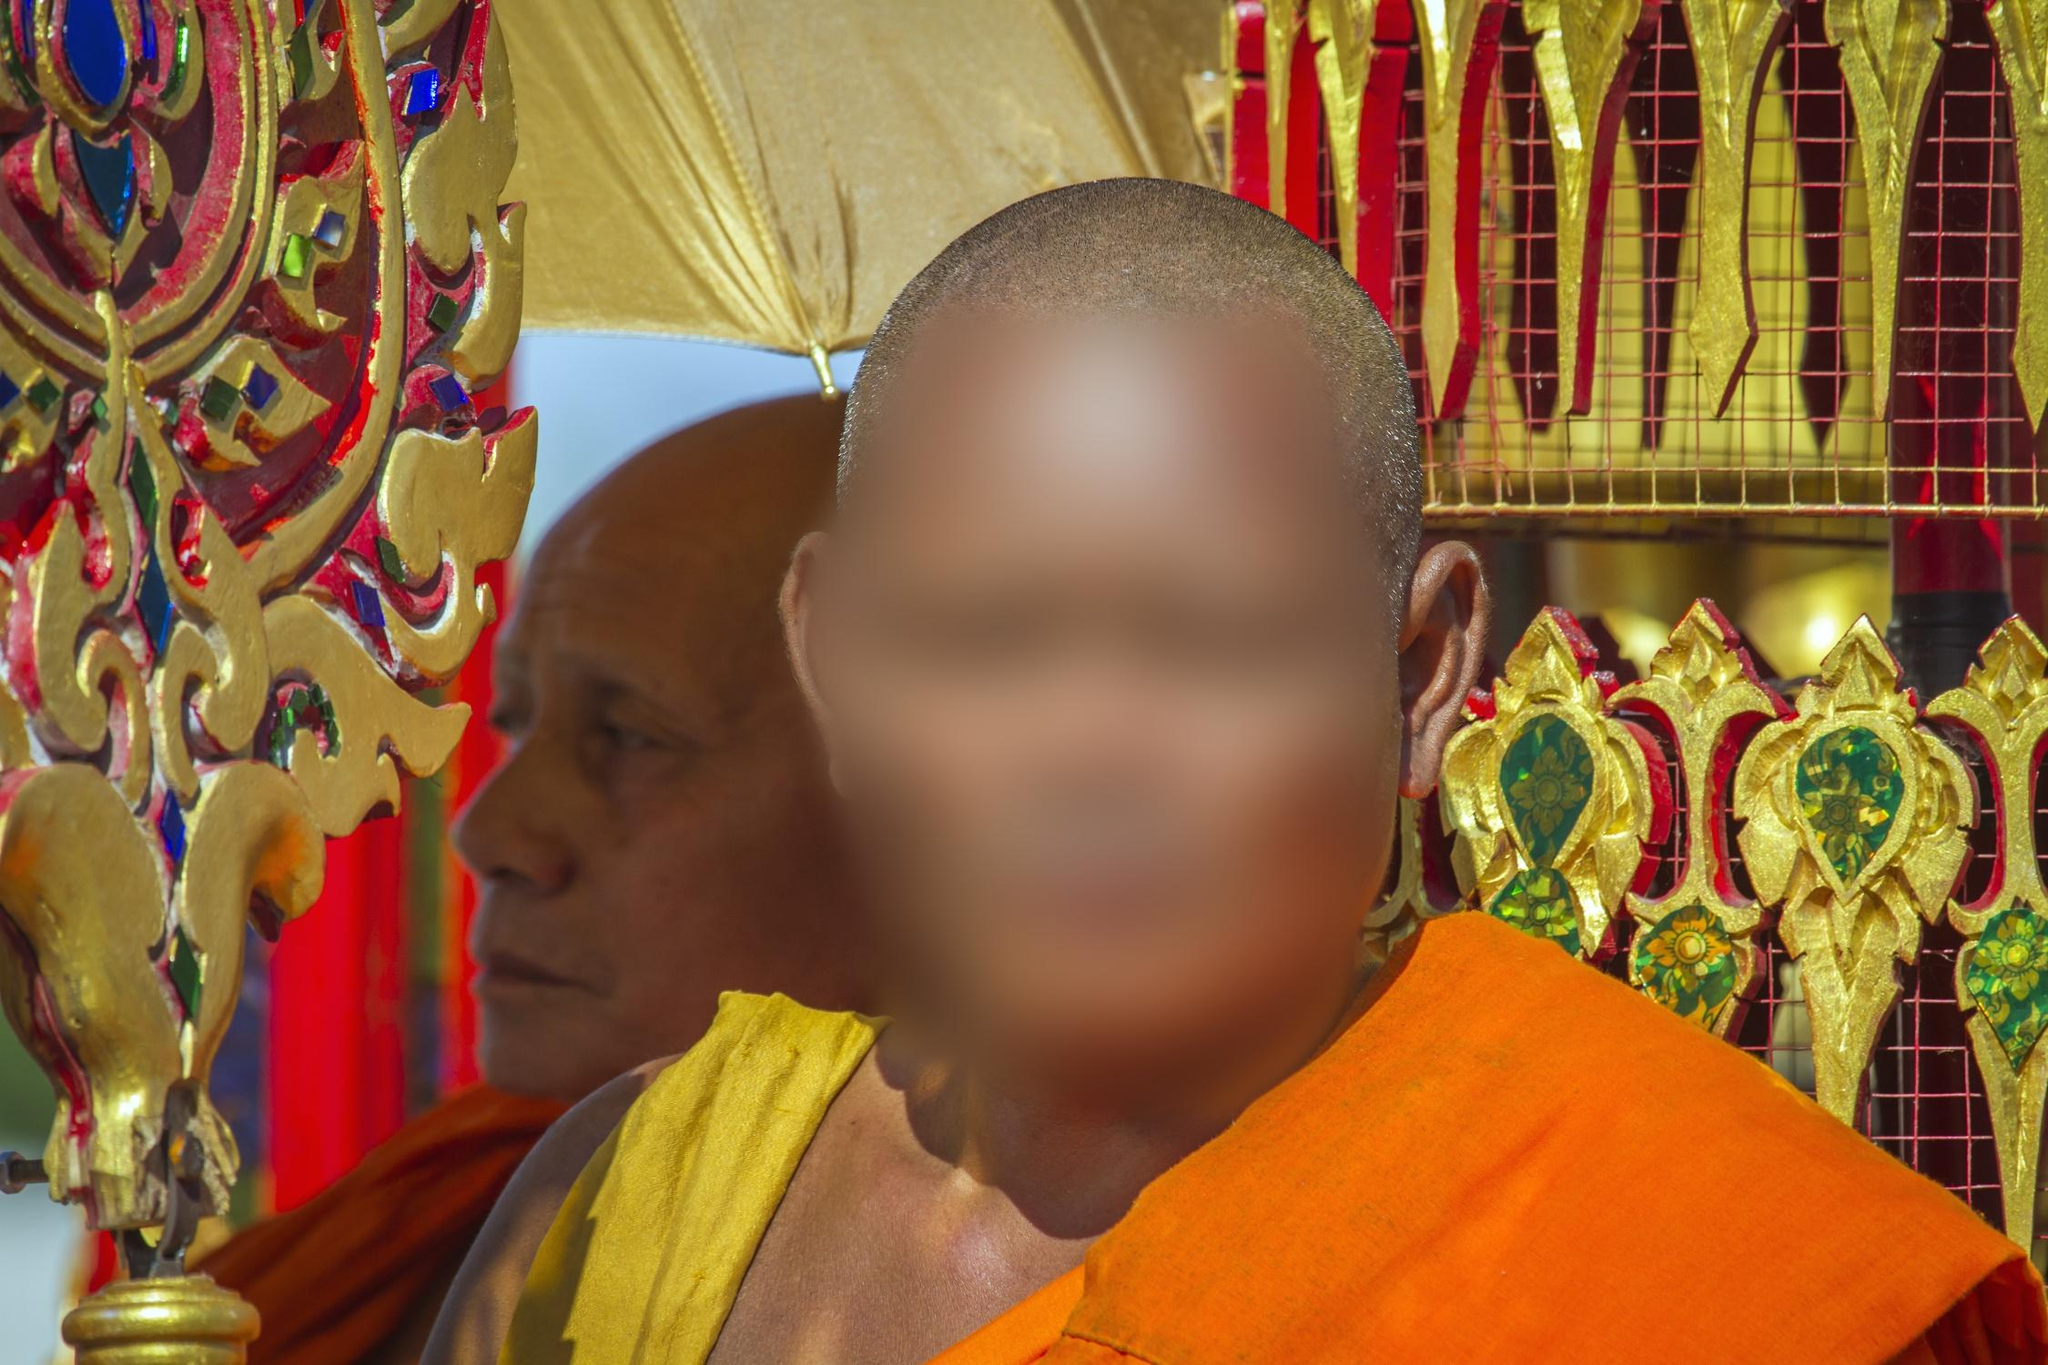Explain the visual content of the image in great detail. The image features two Buddhist monks engaged in a serene moment at a temple. The foreground monk, whose face is respectfully blurred, is clad in a striking orange robe, symbolizing simplicity and detachment from materialism typical in Buddhist beliefs. The background shows another monk and a richly decorated artifact that gleams with golden hues, embedded with traditional Thai patterns and possibly religious symbols. Red and green details suggest the artifact might be ceremonial or hold significant cultural reverence. This moment, caught under natural light that accentuates the vividness of their robes against the opulence of the temple decor, offers a profound insight into the daily spiritual practices and artistic heritage of this religious community. 